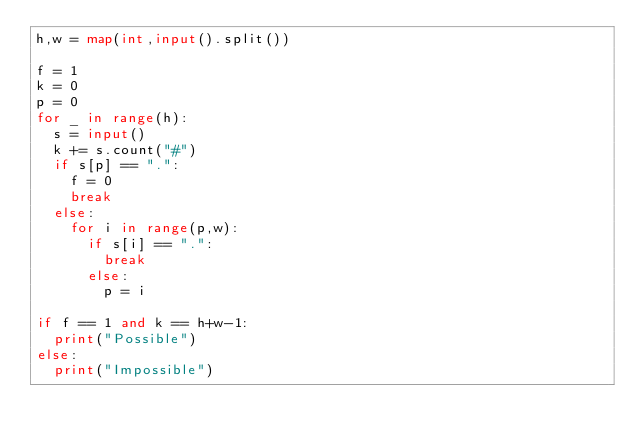<code> <loc_0><loc_0><loc_500><loc_500><_Python_>h,w = map(int,input().split())

f = 1
k = 0
p = 0
for _ in range(h):
  s = input()
  k += s.count("#")
  if s[p] == ".":
    f = 0
    break
  else:
    for i in range(p,w):
      if s[i] == ".":
        break
      else:
        p = i

if f == 1 and k == h+w-1:
  print("Possible")
else:
  print("Impossible")
  
 </code> 